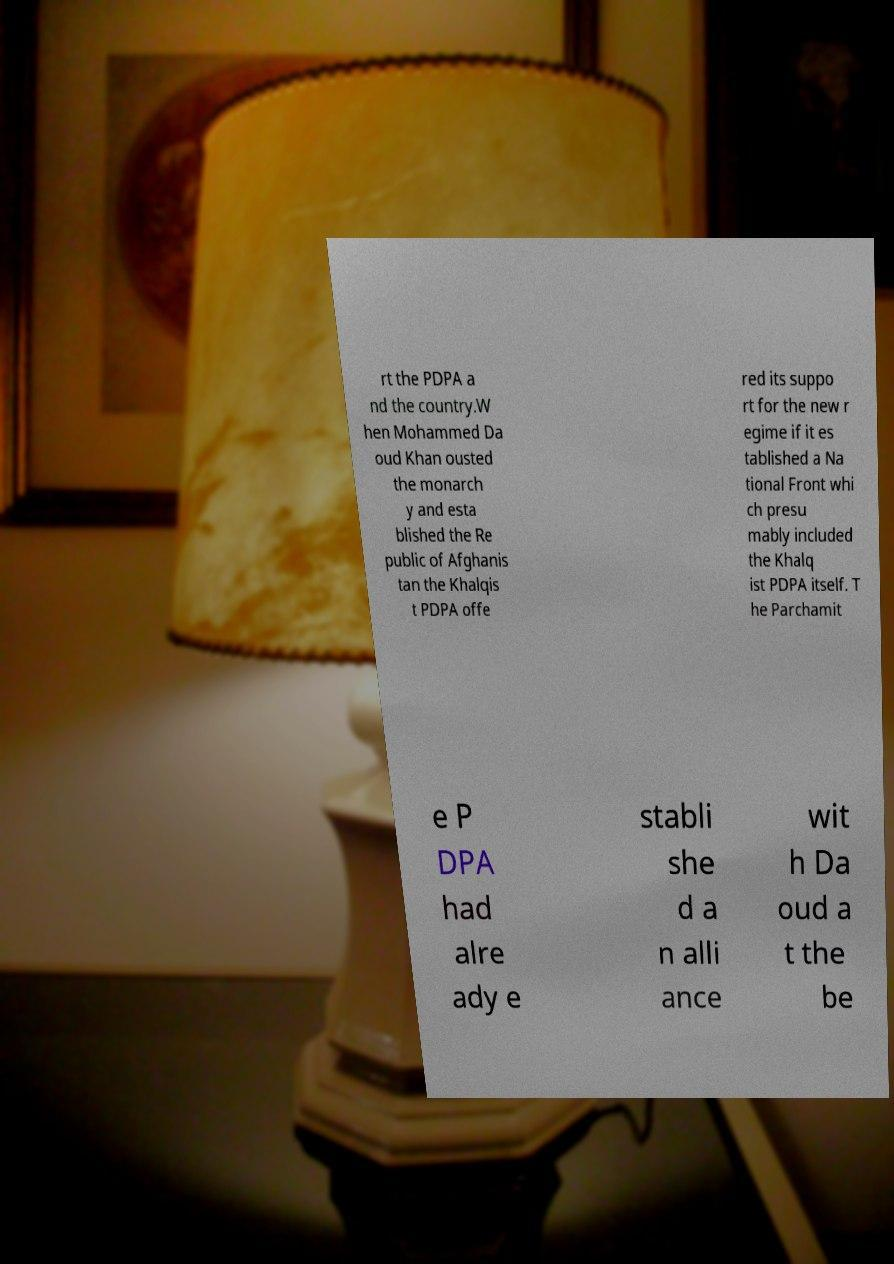I need the written content from this picture converted into text. Can you do that? rt the PDPA a nd the country.W hen Mohammed Da oud Khan ousted the monarch y and esta blished the Re public of Afghanis tan the Khalqis t PDPA offe red its suppo rt for the new r egime if it es tablished a Na tional Front whi ch presu mably included the Khalq ist PDPA itself. T he Parchamit e P DPA had alre ady e stabli she d a n alli ance wit h Da oud a t the be 